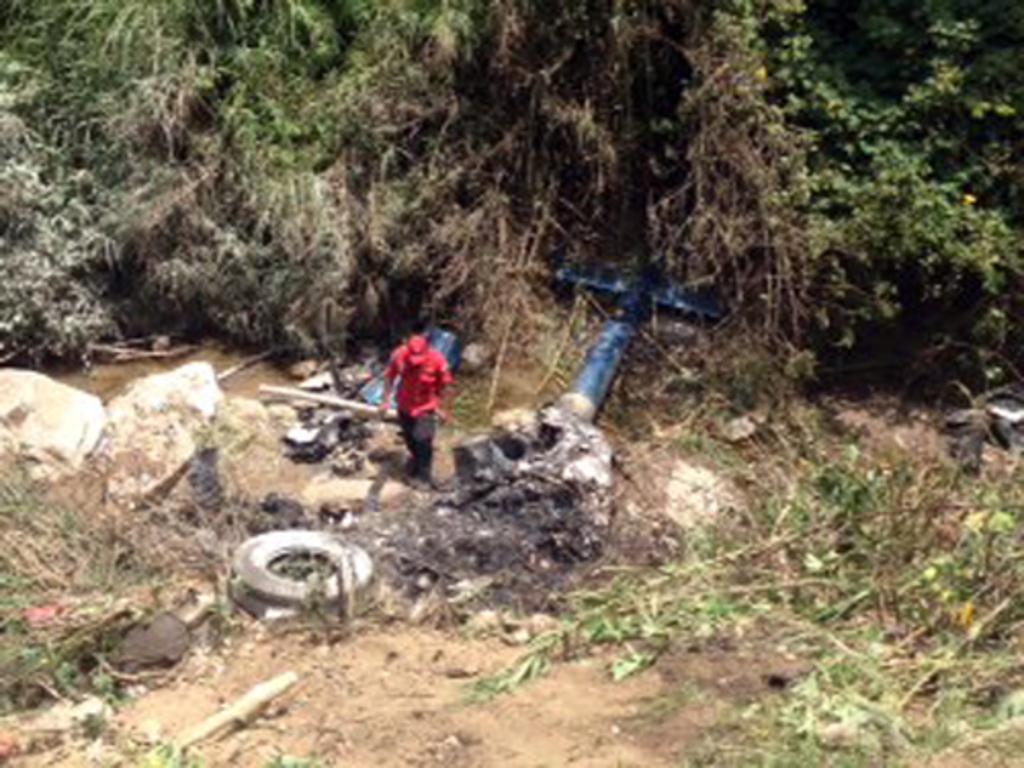How would you summarize this image in a sentence or two? This is an outside view. In the middle of the image I can see a person wearing red color dress, cap on the head and walking on the ground. Around this person I can see some metal objects, mud, rocks and grass. On the top of the image I can see the trees. 